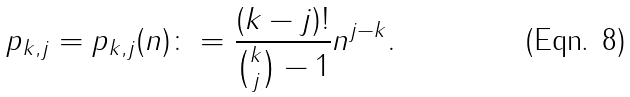<formula> <loc_0><loc_0><loc_500><loc_500>p _ { k , j } = p _ { k , j } ( n ) \colon = \frac { ( k - j ) ! } { \binom { k } { j } - 1 } n ^ { j - k } .</formula> 